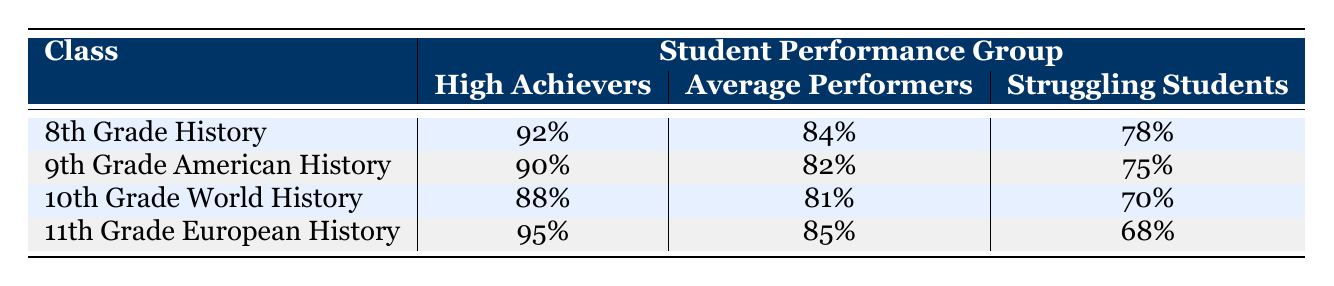What is the attendance rate for 11th Grade European History among High Achievers? The table states that the attendance rate for High Achievers in 11th Grade European History is 95%.
Answer: 95% Which class has the lowest attendance rate for Struggling Students? In the table, the attendance rates for Struggling Students are 78%, 75%, 70%, and 68% for the respective classes. The lowest is 68% for 11th Grade European History.
Answer: 68% What is the average attendance rate for Average Performers across all classes? To find the average attendance rate for Average Performers, we sum the rates: 84% (8th Grade History) + 82% (9th Grade American History) + 81% (10th Grade World History) + 85% (11th Grade European History) = 332%. There are 4 classes, so the average is 332% / 4 = 83%.
Answer: 83% True or False: The attendance rate for High Achievers in 10th Grade World History is greater than 90%. The table shows that the attendance rate for High Achievers in 10th Grade World History is 88%, which is not greater than 90%.
Answer: False What is the difference in attendance rates between Average Performers in 8th Grade History and 9th Grade American History? The attendance rate for Average Performers in 8th Grade History is 84% and in 9th Grade American History is 82%. The difference is 84% - 82% = 2%.
Answer: 2% Which student performance group has the highest attendance rate in 8th Grade History? According to the table, the attendance rates for 8th Grade History are 92% for High Achievers, 84% for Average Performers, and 78% for Struggling Students. Thus, High Achievers have the highest attendance rate.
Answer: High Achievers What is the sum of attendance rates for all performance groups in 10th Grade World History? The attendance rates in 10th Grade World History are 88% for High Achievers, 81% for Average Performers, and 70% for Struggling Students. Adding these gives us 88% + 81% + 70% = 239%.
Answer: 239% True or False: The attendance rate for Average Performers is consistent across all classes. The attendance rates for Average Performers in the table are 84%, 82%, 81%, and 85%, which are not consistent.
Answer: False 